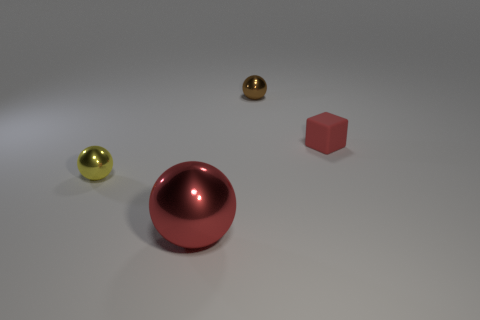Is there any other thing that is the same size as the red metallic object?
Provide a short and direct response. No. Is the number of big shiny balls less than the number of large green rubber objects?
Ensure brevity in your answer.  No. The red thing that is the same shape as the small yellow thing is what size?
Your answer should be compact. Large. Are the red object that is behind the tiny yellow metallic object and the large red object made of the same material?
Your answer should be compact. No. Is the shape of the tiny brown thing the same as the tiny matte object?
Offer a very short reply. No. How many objects are metallic things that are behind the block or small gray blocks?
Provide a short and direct response. 1. There is a red sphere that is made of the same material as the small yellow thing; what is its size?
Make the answer very short. Large. How many other blocks have the same color as the small rubber cube?
Provide a succinct answer. 0. How many large things are either yellow shiny spheres or blue cylinders?
Offer a very short reply. 0. What is the size of the metallic object that is the same color as the small block?
Give a very brief answer. Large. 